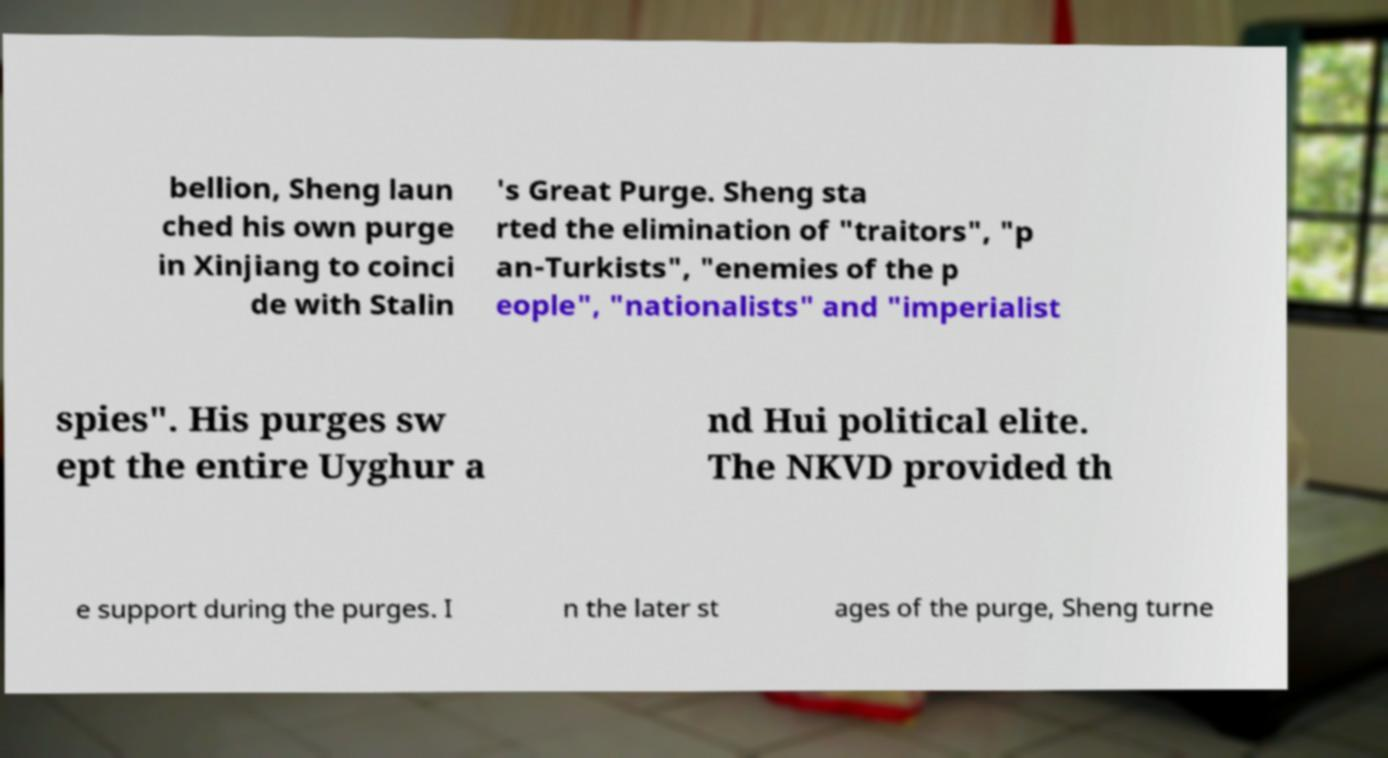Can you accurately transcribe the text from the provided image for me? bellion, Sheng laun ched his own purge in Xinjiang to coinci de with Stalin 's Great Purge. Sheng sta rted the elimination of "traitors", "p an-Turkists", "enemies of the p eople", "nationalists" and "imperialist spies". His purges sw ept the entire Uyghur a nd Hui political elite. The NKVD provided th e support during the purges. I n the later st ages of the purge, Sheng turne 